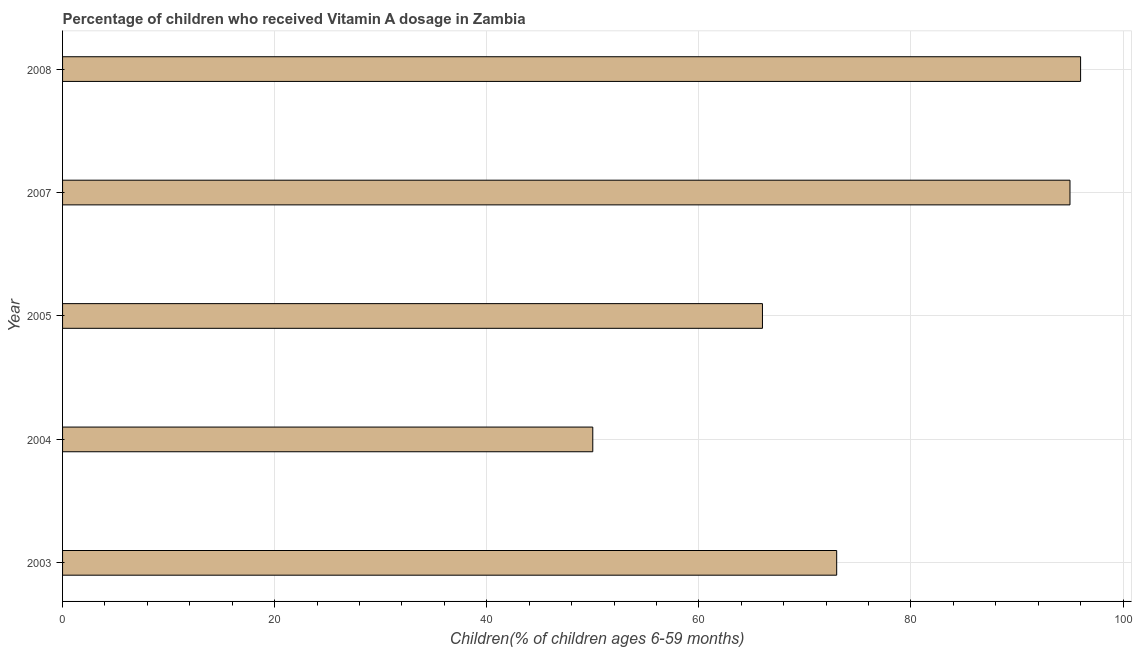Does the graph contain any zero values?
Your answer should be very brief. No. Does the graph contain grids?
Offer a terse response. Yes. What is the title of the graph?
Offer a very short reply. Percentage of children who received Vitamin A dosage in Zambia. What is the label or title of the X-axis?
Ensure brevity in your answer.  Children(% of children ages 6-59 months). What is the vitamin a supplementation coverage rate in 2004?
Give a very brief answer. 50. Across all years, what is the maximum vitamin a supplementation coverage rate?
Keep it short and to the point. 96. Across all years, what is the minimum vitamin a supplementation coverage rate?
Your answer should be compact. 50. In which year was the vitamin a supplementation coverage rate maximum?
Your answer should be very brief. 2008. In which year was the vitamin a supplementation coverage rate minimum?
Make the answer very short. 2004. What is the sum of the vitamin a supplementation coverage rate?
Offer a very short reply. 380. What is the median vitamin a supplementation coverage rate?
Offer a very short reply. 73. In how many years, is the vitamin a supplementation coverage rate greater than 68 %?
Provide a short and direct response. 3. Do a majority of the years between 2007 and 2004 (inclusive) have vitamin a supplementation coverage rate greater than 20 %?
Keep it short and to the point. Yes. What is the ratio of the vitamin a supplementation coverage rate in 2004 to that in 2007?
Your response must be concise. 0.53. Is the sum of the vitamin a supplementation coverage rate in 2005 and 2008 greater than the maximum vitamin a supplementation coverage rate across all years?
Give a very brief answer. Yes. How many bars are there?
Offer a very short reply. 5. How many years are there in the graph?
Your answer should be compact. 5. What is the difference between two consecutive major ticks on the X-axis?
Ensure brevity in your answer.  20. Are the values on the major ticks of X-axis written in scientific E-notation?
Your response must be concise. No. What is the Children(% of children ages 6-59 months) of 2003?
Give a very brief answer. 73. What is the Children(% of children ages 6-59 months) in 2008?
Give a very brief answer. 96. What is the difference between the Children(% of children ages 6-59 months) in 2003 and 2005?
Provide a succinct answer. 7. What is the difference between the Children(% of children ages 6-59 months) in 2003 and 2007?
Give a very brief answer. -22. What is the difference between the Children(% of children ages 6-59 months) in 2004 and 2005?
Make the answer very short. -16. What is the difference between the Children(% of children ages 6-59 months) in 2004 and 2007?
Your answer should be very brief. -45. What is the difference between the Children(% of children ages 6-59 months) in 2004 and 2008?
Your response must be concise. -46. What is the difference between the Children(% of children ages 6-59 months) in 2005 and 2007?
Provide a short and direct response. -29. What is the difference between the Children(% of children ages 6-59 months) in 2005 and 2008?
Your answer should be very brief. -30. What is the ratio of the Children(% of children ages 6-59 months) in 2003 to that in 2004?
Ensure brevity in your answer.  1.46. What is the ratio of the Children(% of children ages 6-59 months) in 2003 to that in 2005?
Give a very brief answer. 1.11. What is the ratio of the Children(% of children ages 6-59 months) in 2003 to that in 2007?
Keep it short and to the point. 0.77. What is the ratio of the Children(% of children ages 6-59 months) in 2003 to that in 2008?
Give a very brief answer. 0.76. What is the ratio of the Children(% of children ages 6-59 months) in 2004 to that in 2005?
Provide a short and direct response. 0.76. What is the ratio of the Children(% of children ages 6-59 months) in 2004 to that in 2007?
Keep it short and to the point. 0.53. What is the ratio of the Children(% of children ages 6-59 months) in 2004 to that in 2008?
Your response must be concise. 0.52. What is the ratio of the Children(% of children ages 6-59 months) in 2005 to that in 2007?
Offer a terse response. 0.69. What is the ratio of the Children(% of children ages 6-59 months) in 2005 to that in 2008?
Keep it short and to the point. 0.69. 